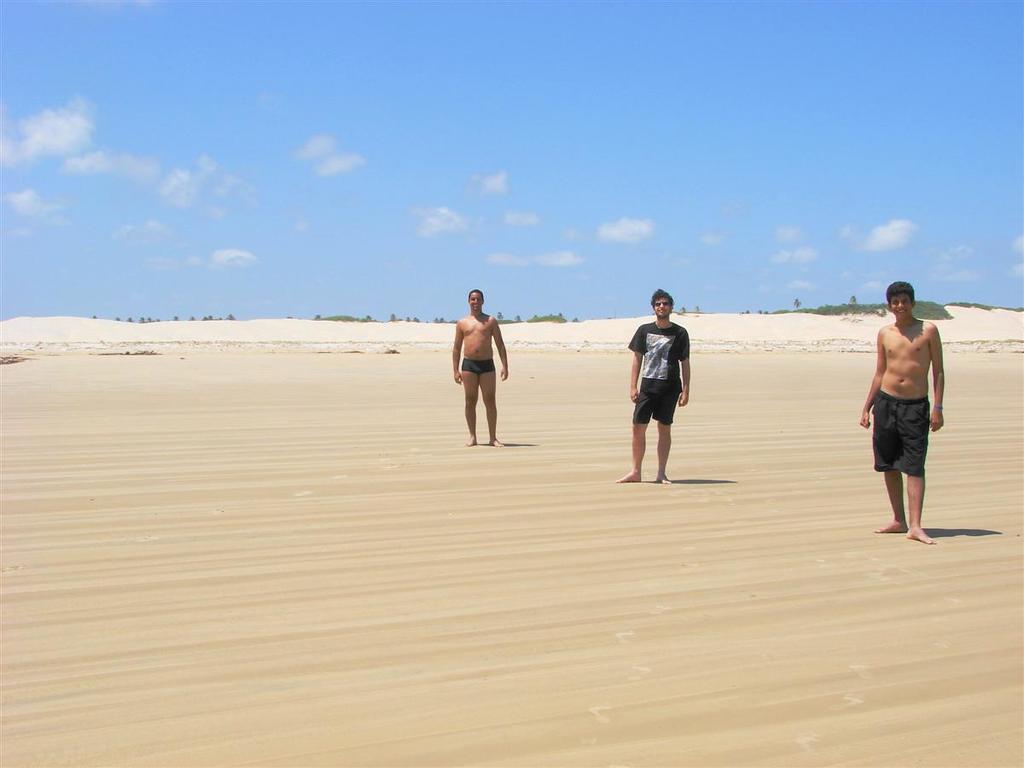Can you describe this image briefly? In this image we can see three mans are standing. In the center of the image trees, hills are there. At the bottom of the image ground is there. At the top of the image clouds are present in the sky. 